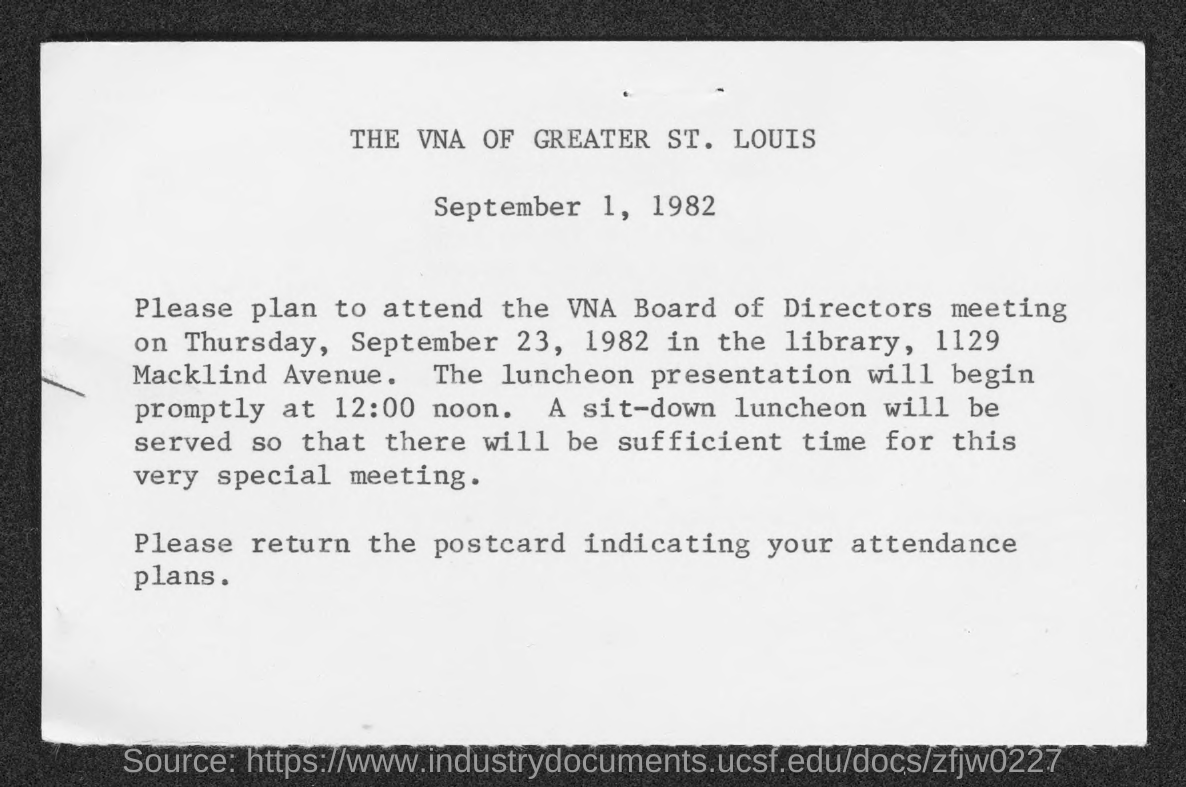What is the date mentioned in the top of the document ?
Offer a terse response. September 1, 1982. 